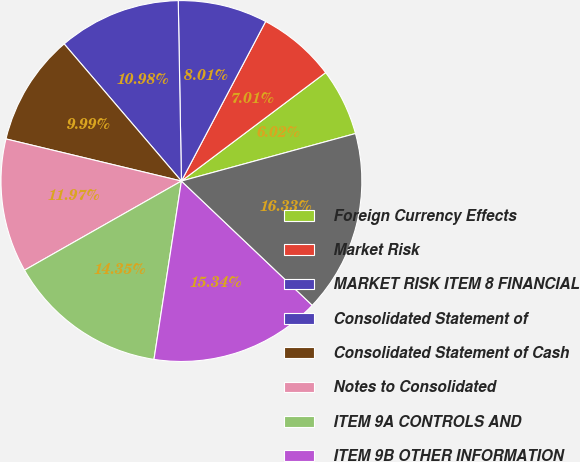<chart> <loc_0><loc_0><loc_500><loc_500><pie_chart><fcel>Foreign Currency Effects<fcel>Market Risk<fcel>MARKET RISK ITEM 8 FINANCIAL<fcel>Consolidated Statement of<fcel>Consolidated Statement of Cash<fcel>Notes to Consolidated<fcel>ITEM 9A CONTROLS AND<fcel>ITEM 9B OTHER INFORMATION<fcel>ITEM 10 DIRECTORS AND<nl><fcel>6.02%<fcel>7.01%<fcel>8.01%<fcel>10.98%<fcel>9.99%<fcel>11.97%<fcel>14.35%<fcel>15.34%<fcel>16.33%<nl></chart> 